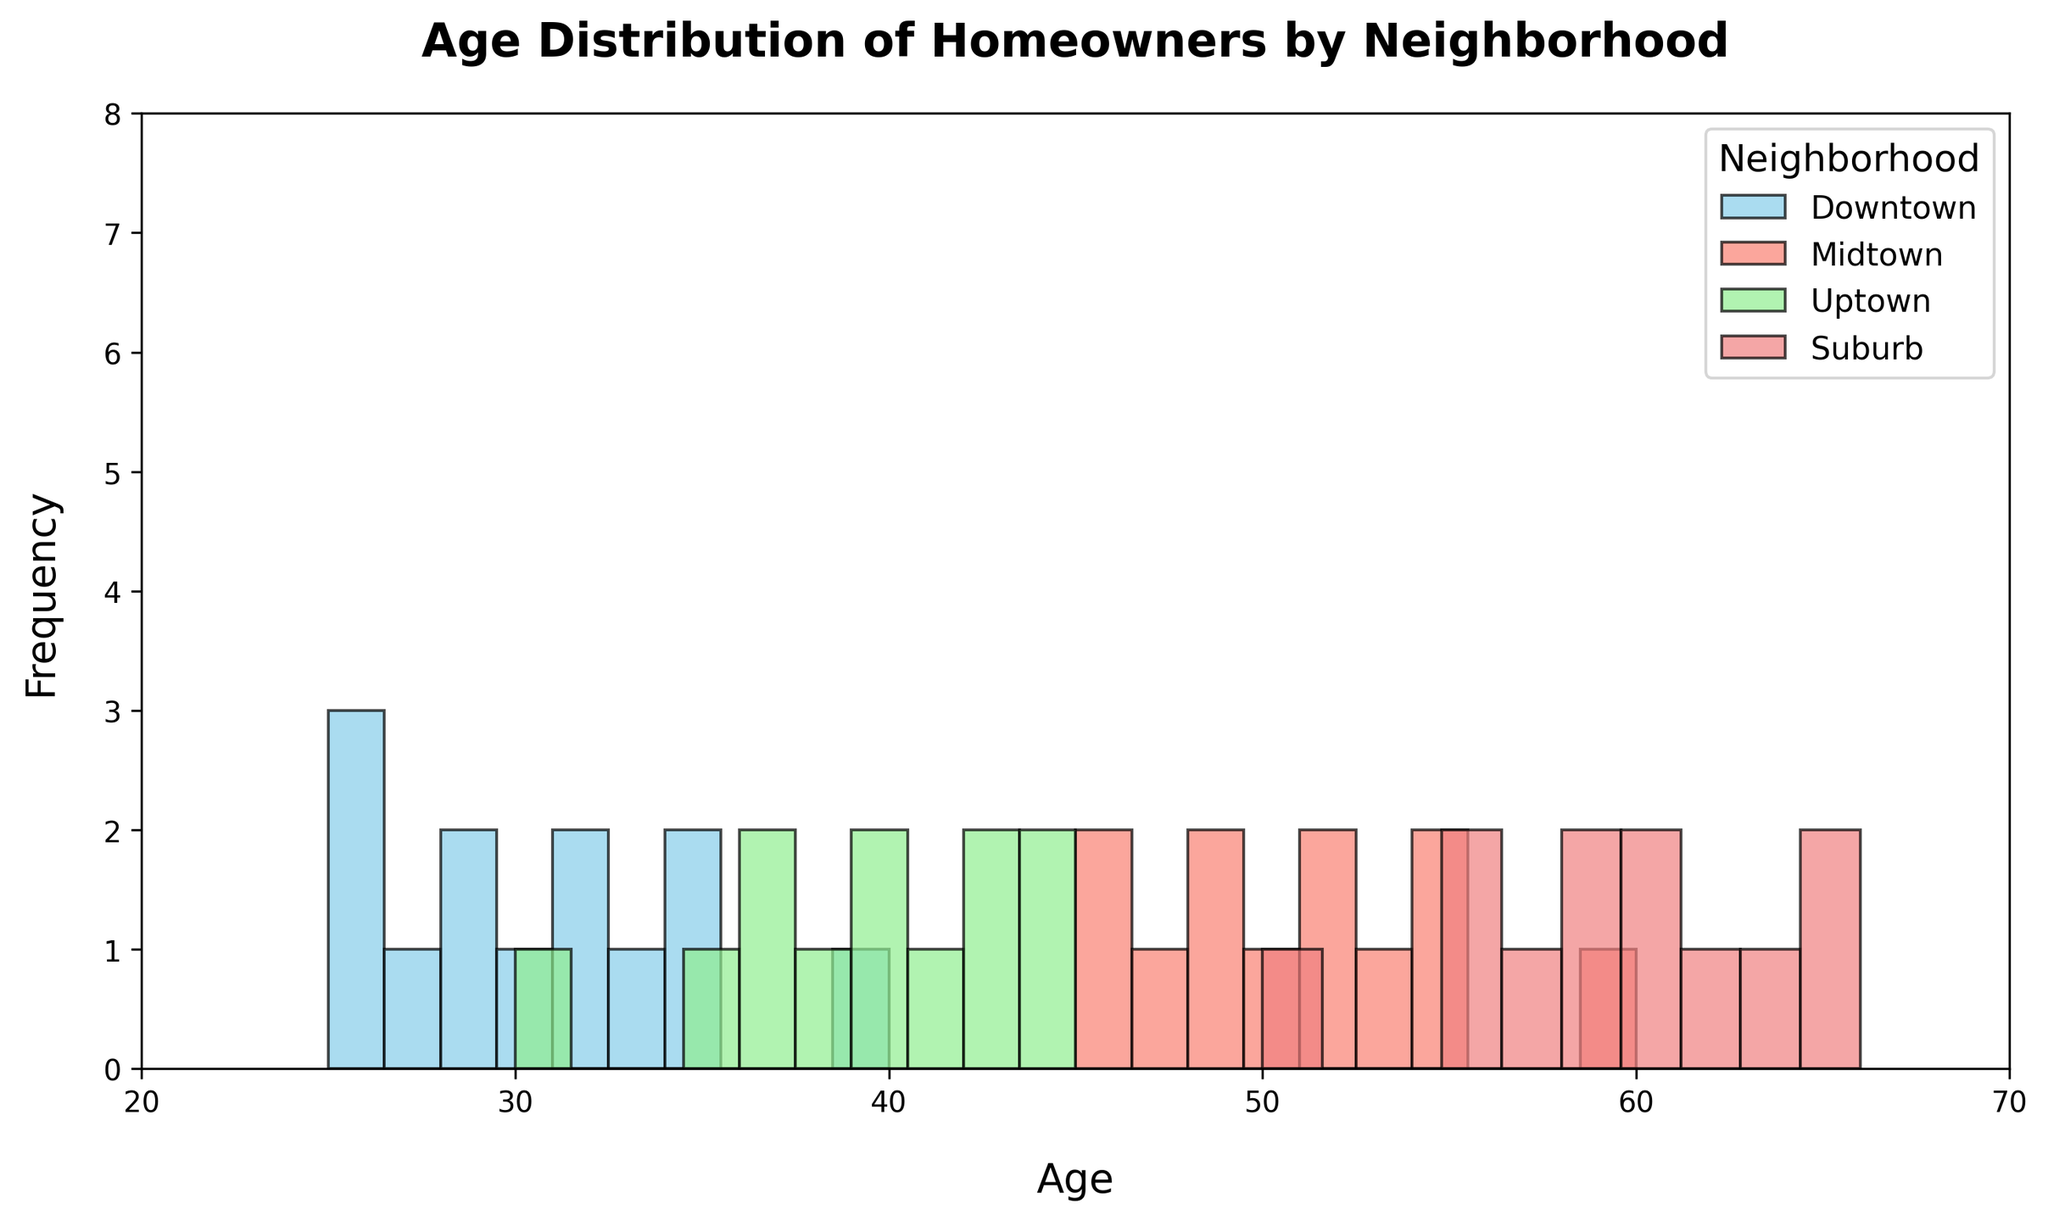What's the most common age range for homeowners in the Downtown neighborhood? Looking at the histogram, the highest bars for Downtown fall in the 25-35 age range. These bars represent the most frequent age range for homeowners in this neighborhood.
Answer: 25-35 Which neighborhood has the most even distribution of homeowner ages? By observing the histograms for each neighborhood, Midtown stands out as having a fairly even distribution of ages from around 45 to 60. This indicates that the homeowner ages in Midtown are more evenly spread out than in other neighborhoods.
Answer: Midtown What is the approximate median age for homeowners in the Suburb neighborhood? The histogram for Suburb shows ages ranging from 50 to 65. With each age range appearing fairly frequently and symmetrically, the median age can be estimated to be around the middle of this range, approximately 57.5.
Answer: 57.5 How does the age distribution of Downtown compare to Uptown? Downtown has a more concentrated age range of 25-40 with higher peaks at younger ages, whereas Uptown shows a wider age range of 30-45 with a more even distribution. This suggests that Downtown homeowners tend to be younger, whereas Uptown has a more diverse age group.
Answer: Downtown has younger homeowners; Uptown has a more diverse age group Which neighborhood has the highest frequency of homeowners aged 50 and above? By looking at the histograms, Suburb has the highest frequency of bars representing ages 50 and above, indicating that this is the neighborhood with the most homeowners in this age range.
Answer: Suburb What is the visual difference between histograms of Midtown and Suburb when compared in terms of bar height and spread? The Midtown histogram shows a spread across 45-55 with each bar having similar moderate heights, indicating an even distribution. In contrast, Suburb has bars from 50-65 with taller heights, showing a concentrated and higher frequency of older homeowners.
Answer: Even distribution in Midtown; concentrated, higher frequency in Suburb If you sum the highest frequency counts for all neighborhoods, which neighborhood has the single highest peak? By visually summing up the bar heights, it is clear that Suburb has the tallest bar overall, indicating the highest single frequency count among all neighborhoods.
Answer: Suburb Between which two neighborhoods is there the most noticeable difference in the age distribution of homeowners? Comparing the histograms, there is a noticeable contrast between Downtown and Suburb. Downtown has a younger age distribution mainly from 25-40, while Suburb has an older age range from 50-65.
Answer: Downtown and Suburb 